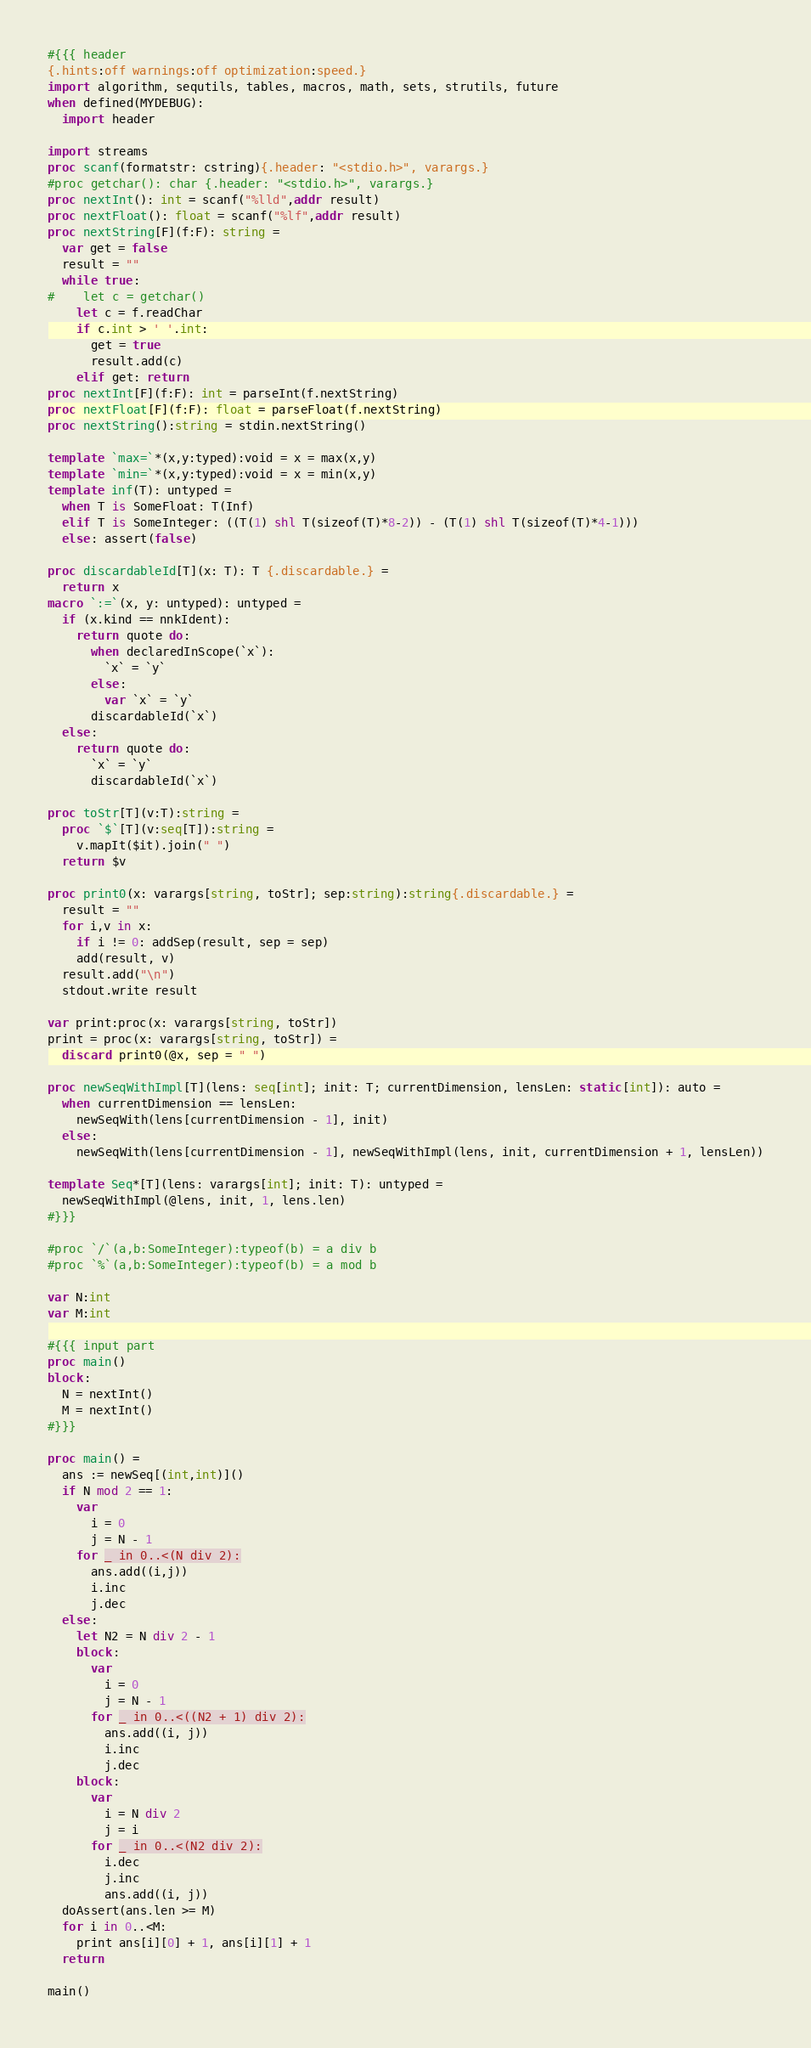Convert code to text. <code><loc_0><loc_0><loc_500><loc_500><_Nim_>#{{{ header
{.hints:off warnings:off optimization:speed.}
import algorithm, sequtils, tables, macros, math, sets, strutils, future
when defined(MYDEBUG):
  import header

import streams
proc scanf(formatstr: cstring){.header: "<stdio.h>", varargs.}
#proc getchar(): char {.header: "<stdio.h>", varargs.}
proc nextInt(): int = scanf("%lld",addr result)
proc nextFloat(): float = scanf("%lf",addr result)
proc nextString[F](f:F): string =
  var get = false
  result = ""
  while true:
#    let c = getchar()
    let c = f.readChar
    if c.int > ' '.int:
      get = true
      result.add(c)
    elif get: return
proc nextInt[F](f:F): int = parseInt(f.nextString)
proc nextFloat[F](f:F): float = parseFloat(f.nextString)
proc nextString():string = stdin.nextString()

template `max=`*(x,y:typed):void = x = max(x,y)
template `min=`*(x,y:typed):void = x = min(x,y)
template inf(T): untyped = 
  when T is SomeFloat: T(Inf)
  elif T is SomeInteger: ((T(1) shl T(sizeof(T)*8-2)) - (T(1) shl T(sizeof(T)*4-1)))
  else: assert(false)

proc discardableId[T](x: T): T {.discardable.} =
  return x
macro `:=`(x, y: untyped): untyped =
  if (x.kind == nnkIdent):
    return quote do:
      when declaredInScope(`x`):
        `x` = `y`
      else:
        var `x` = `y`
      discardableId(`x`)
  else:
    return quote do:
      `x` = `y`
      discardableId(`x`)

proc toStr[T](v:T):string =
  proc `$`[T](v:seq[T]):string =
    v.mapIt($it).join(" ")
  return $v

proc print0(x: varargs[string, toStr]; sep:string):string{.discardable.} =
  result = ""
  for i,v in x:
    if i != 0: addSep(result, sep = sep)
    add(result, v)
  result.add("\n")
  stdout.write result

var print:proc(x: varargs[string, toStr])
print = proc(x: varargs[string, toStr]) =
  discard print0(@x, sep = " ")

proc newSeqWithImpl[T](lens: seq[int]; init: T; currentDimension, lensLen: static[int]): auto =
  when currentDimension == lensLen:
    newSeqWith(lens[currentDimension - 1], init)
  else:
    newSeqWith(lens[currentDimension - 1], newSeqWithImpl(lens, init, currentDimension + 1, lensLen))

template Seq*[T](lens: varargs[int]; init: T): untyped =
  newSeqWithImpl(@lens, init, 1, lens.len)
#}}}

#proc `/`(a,b:SomeInteger):typeof(b) = a div b
#proc `%`(a,b:SomeInteger):typeof(b) = a mod b

var N:int
var M:int

#{{{ input part
proc main()
block:
  N = nextInt()
  M = nextInt()
#}}}

proc main() =
  ans := newSeq[(int,int)]()
  if N mod 2 == 1:
    var
      i = 0
      j = N - 1
    for _ in 0..<(N div 2):
      ans.add((i,j))
      i.inc
      j.dec
  else:
    let N2 = N div 2 - 1
    block:
      var
        i = 0
        j = N - 1
      for _ in 0..<((N2 + 1) div 2):
        ans.add((i, j))
        i.inc
        j.dec
    block:
      var
        i = N div 2
        j = i
      for _ in 0..<(N2 div 2):
        i.dec
        j.inc
        ans.add((i, j))
  doAssert(ans.len >= M)
  for i in 0..<M:
    print ans[i][0] + 1, ans[i][1] + 1
  return

main()</code> 